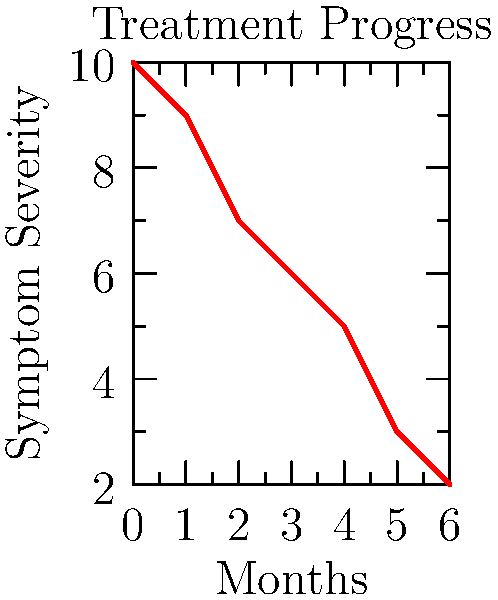Based on the line chart showing PTSD symptom severity over six months of treatment, what is the average rate of symptom reduction per month? To calculate the average rate of symptom reduction per month:

1. Identify initial and final symptom severity:
   Initial (month 0): 10
   Final (month 6): 2

2. Calculate total reduction:
   $10 - 2 = 8$

3. Divide total reduction by number of months:
   $8 \div 6 = 1.33$

4. Round to two decimal places:
   $1.33$ (rounded)

Therefore, the average rate of symptom reduction is 1.33 points per month.
Answer: 1.33 points/month 